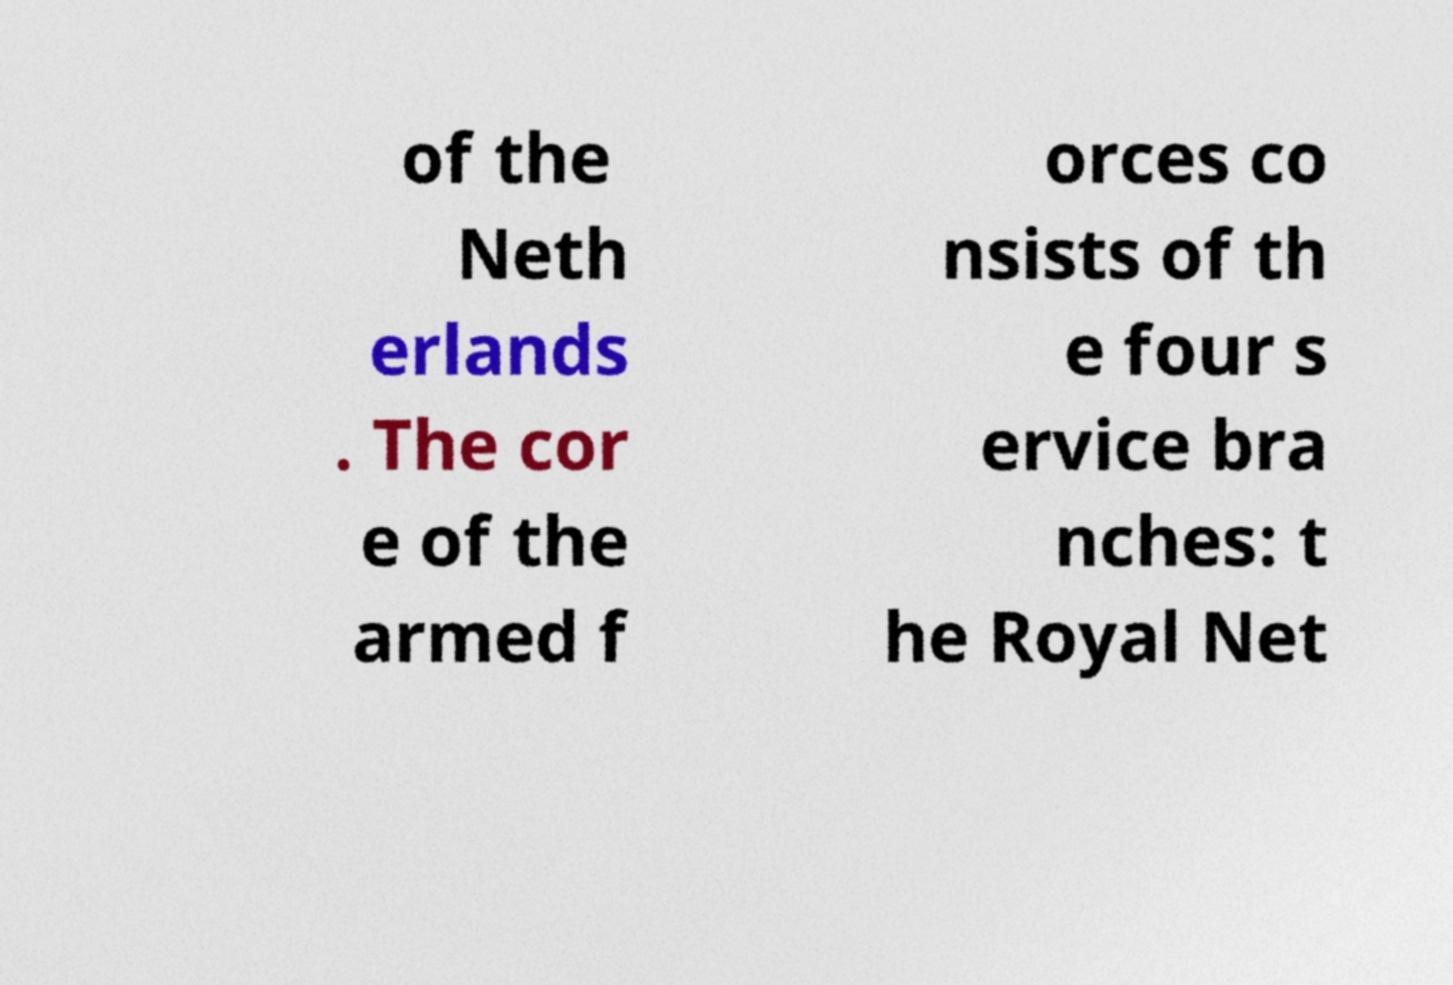Please identify and transcribe the text found in this image. of the Neth erlands . The cor e of the armed f orces co nsists of th e four s ervice bra nches: t he Royal Net 